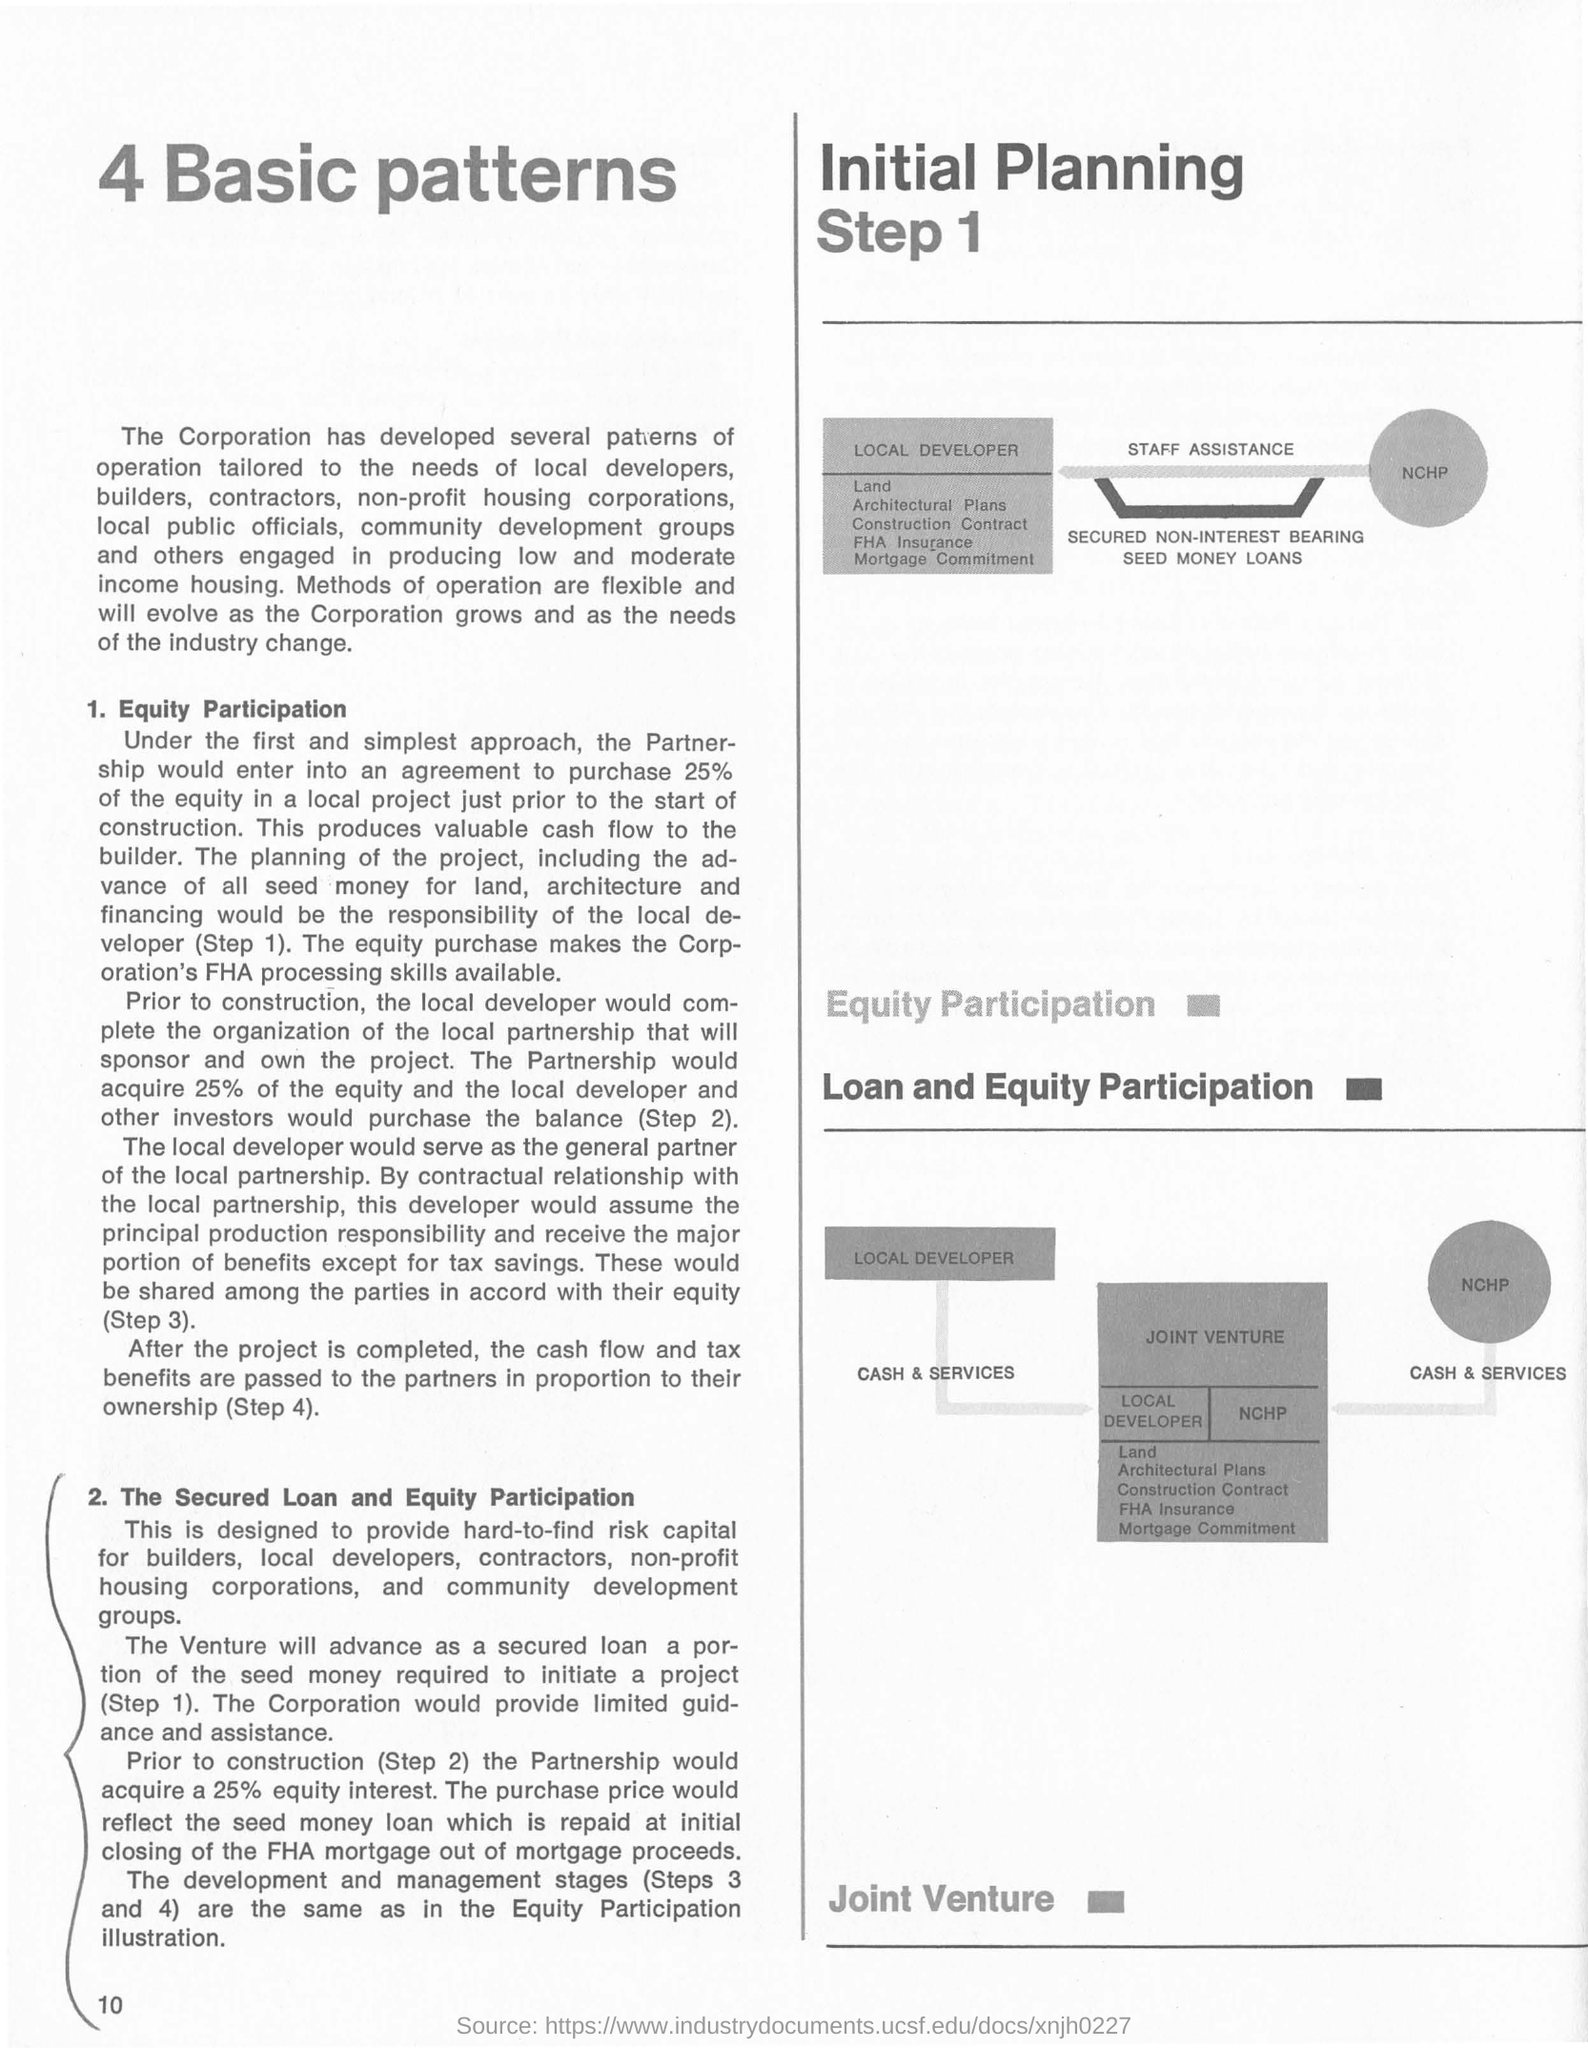Highlight a few significant elements in this photo. The first subtitle under the title '4 Basic Patterns' is '1. Equity Participation.' The number of basic patterns listed at the top right corner of the page is 4. 